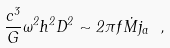<formula> <loc_0><loc_0><loc_500><loc_500>\frac { c ^ { 3 } } { G } \omega ^ { 2 } h ^ { 2 } D ^ { 2 } \sim 2 \pi f \dot { M } j _ { a } \ ,</formula> 